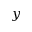Convert formula to latex. <formula><loc_0><loc_0><loc_500><loc_500>y</formula> 